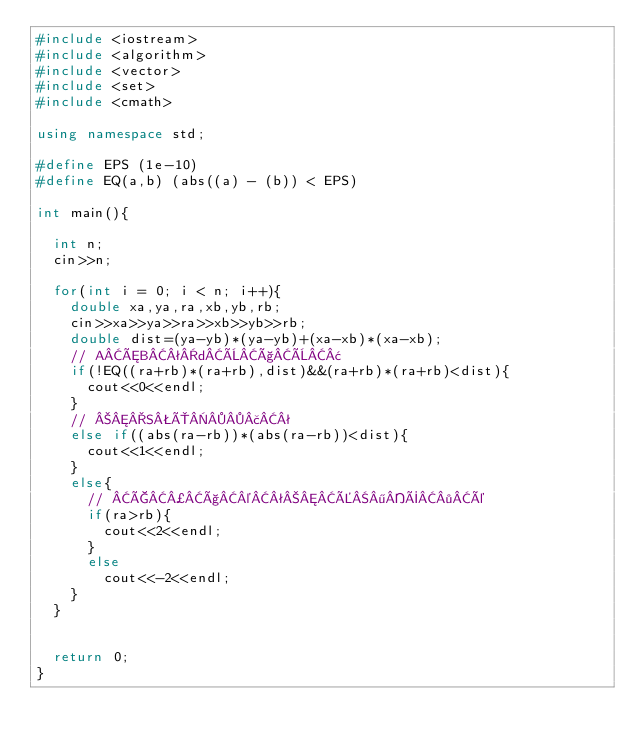<code> <loc_0><loc_0><loc_500><loc_500><_C++_>#include <iostream>
#include <algorithm>
#include <vector>
#include <set>
#include <cmath>

using namespace std;

#define EPS (1e-10)
#define EQ(a,b) (abs((a) - (b)) < EPS)

int main(){

	int n;
	cin>>n;

	for(int i = 0; i < n; i++){
		double xa,ya,ra,xb,yb,rb;
		cin>>xa>>ya>>ra>>xb>>yb>>rb;
		double dist=(ya-yb)*(ya-yb)+(xa-xb)*(xa-xb);
		// AÆBªdÈçÈ¢
		if(!EQ((ra+rb)*(ra+rb),dist)&&(ra+rb)*(ra+rb)<dist){
			cout<<0<<endl;
		}
		// SÔ£ª
		else if((abs(ra-rb))*(abs(ra-rb))<dist){
			cout<<1<<endl;
		}
		else{
			// Ç¿ç©ªÉ¶Ý·é
			if(ra>rb){
				cout<<2<<endl;
			}
			else
				cout<<-2<<endl;
		}
	}


	return 0;
}</code> 